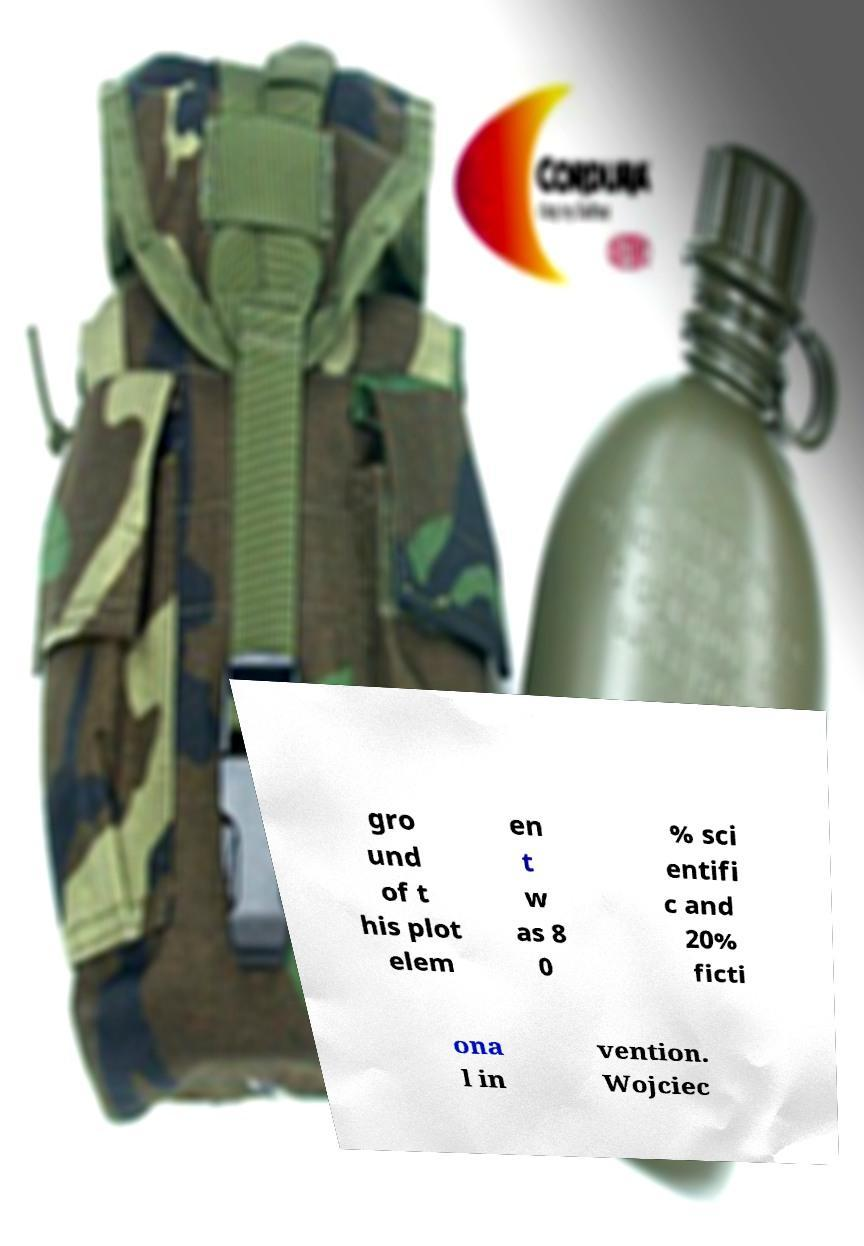For documentation purposes, I need the text within this image transcribed. Could you provide that? gro und of t his plot elem en t w as 8 0 % sci entifi c and 20% ficti ona l in vention. Wojciec 